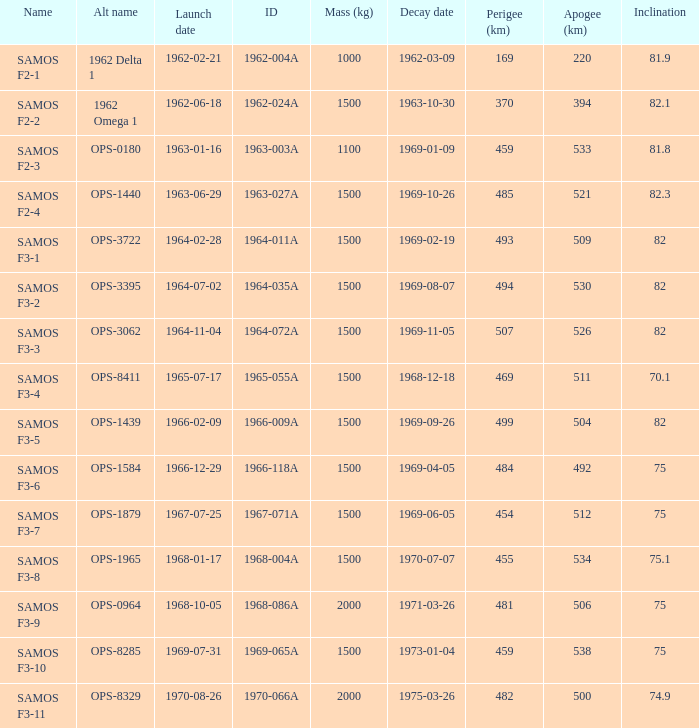How many alt names does 1964-011a have? 1.0. 